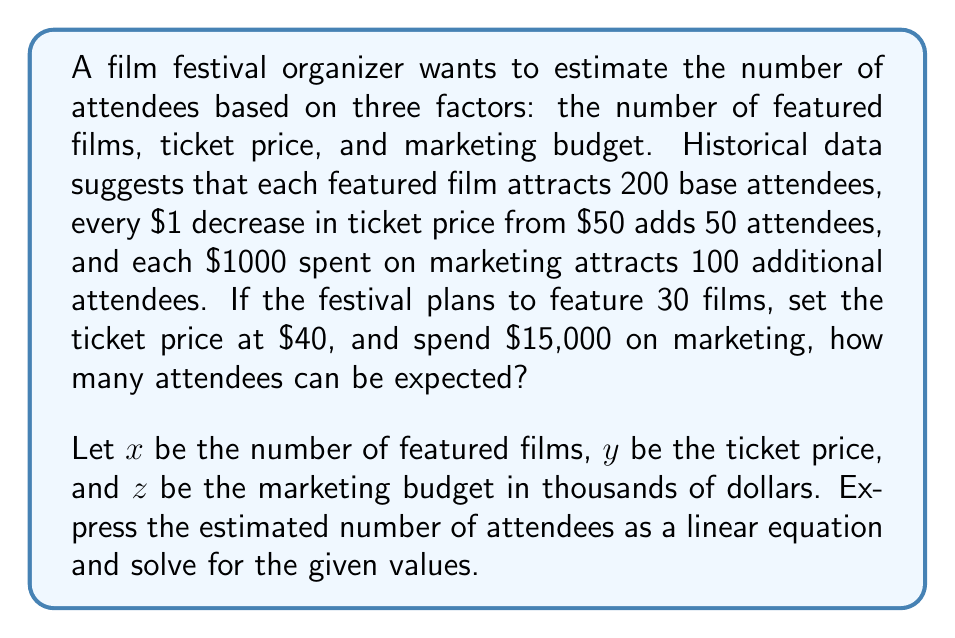Help me with this question. To solve this problem, we'll follow these steps:

1. Formulate the linear equation based on the given information:
   - Base attendees per film: 200x
   - Additional attendees due to ticket price: 50(50 - y)
   - Additional attendees due to marketing: 100z

   The linear equation for estimated attendees (A) is:
   $$A = 200x + 50(50 - y) + 100z$$

2. Simplify the equation:
   $$A = 200x + 2500 - 50y + 100z$$

3. Substitute the given values:
   x = 30 (number of featured films)
   y = 40 (ticket price)
   z = 15 (marketing budget in thousands)

4. Calculate the estimated number of attendees:
   $$A = 200(30) + 2500 - 50(40) + 100(15)$$
   $$A = 6000 + 2500 - 2000 + 1500$$
   $$A = 8000$$

Therefore, the estimated number of attendees for the film festival is 8,000.
Answer: 8,000 attendees 